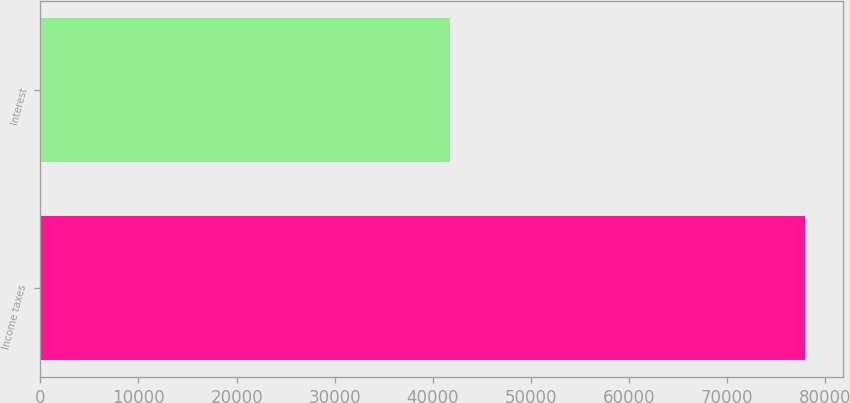<chart> <loc_0><loc_0><loc_500><loc_500><bar_chart><fcel>Income taxes<fcel>Interest<nl><fcel>77918<fcel>41701<nl></chart> 